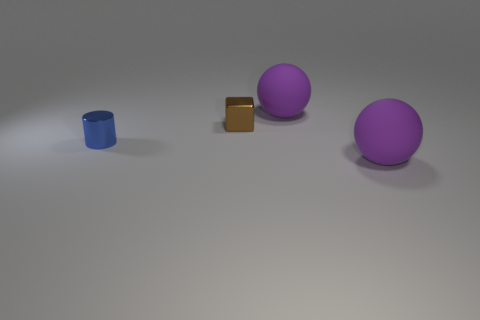Add 3 large matte things. How many objects exist? 7 Subtract all blue cubes. How many red spheres are left? 0 Subtract all tiny red metal spheres. Subtract all big matte balls. How many objects are left? 2 Add 4 small brown shiny cubes. How many small brown shiny cubes are left? 5 Add 1 tiny blue cylinders. How many tiny blue cylinders exist? 2 Subtract 1 brown blocks. How many objects are left? 3 Subtract all cylinders. How many objects are left? 3 Subtract 2 balls. How many balls are left? 0 Subtract all blue spheres. Subtract all purple cylinders. How many spheres are left? 2 